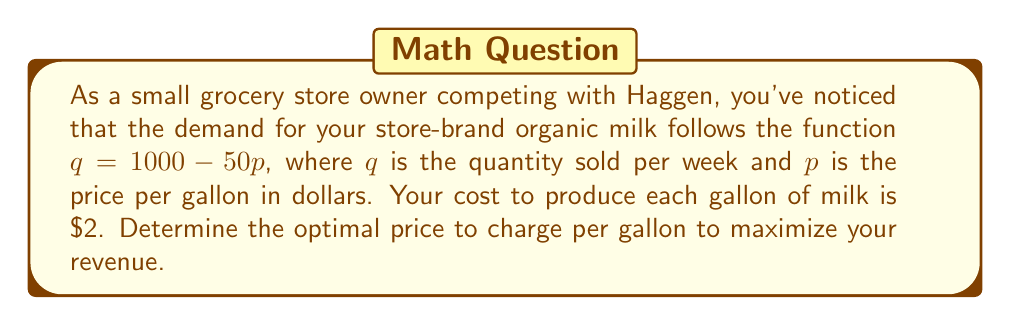Can you solve this math problem? To solve this problem, we'll follow these steps:

1) First, let's define the revenue function. Revenue is price times quantity:
   $R = pq = p(1000 - 50p) = 1000p - 50p^2$

2) To maximize revenue, we need to find the derivative of R with respect to p and set it equal to zero:
   $$\frac{dR}{dp} = 1000 - 100p$$

3) Set this equal to zero and solve for p:
   $$1000 - 100p = 0$$
   $$100p = 1000$$
   $$p = 10$$

4) To confirm this is a maximum, we can check the second derivative:
   $$\frac{d^2R}{dp^2} = -100$$
   Since this is negative, we confirm that $p = 10$ gives a maximum.

5) At $p = 10$, the quantity sold would be:
   $q = 1000 - 50(10) = 500$ gallons per week

6) The revenue at this price would be:
   $R = 10 * 500 = 5000$ dollars per week

7) Note that this maximizes revenue, not profit. To maximize profit, we would need to consider the cost of $2 per gallon. However, the question asks specifically about revenue maximization.
Answer: $10 per gallon 